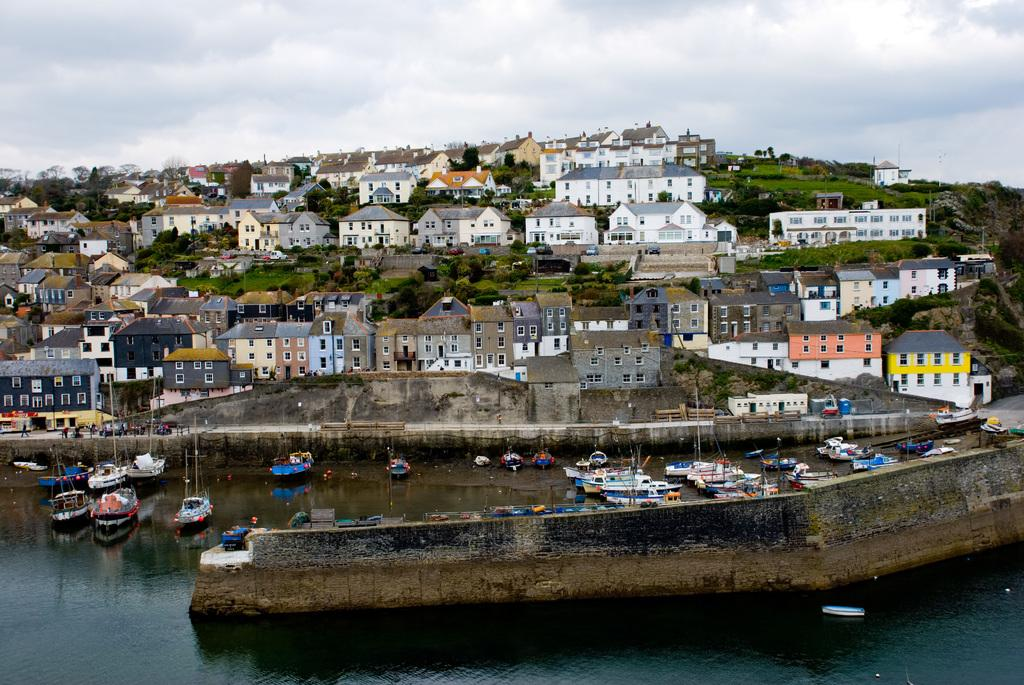What is in the front of the image? There is water in the front of the image. What is on the water? There are boats on the water. What can be seen in the background of the image? There are buildings, trees, clouds, and the sky visible in the background of the image. What is the purpose of the writer in the image? There is no writer present in the image; it features water, boats, buildings, trees, clouds, and the sky. What type of man can be seen walking on the water in the image? There is no man walking on the water in the image; it features water, boats, buildings, trees, clouds, and the sky. 